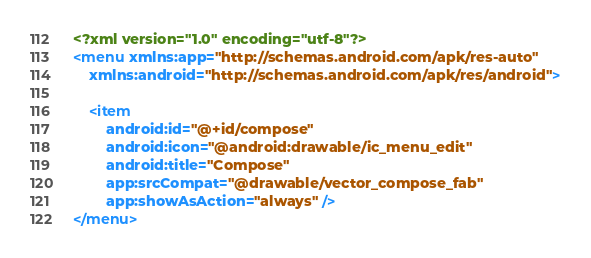<code> <loc_0><loc_0><loc_500><loc_500><_XML_><?xml version="1.0" encoding="utf-8"?>
<menu xmlns:app="http://schemas.android.com/apk/res-auto"
    xmlns:android="http://schemas.android.com/apk/res/android">

    <item
        android:id="@+id/compose"
        android:icon="@android:drawable/ic_menu_edit"
        android:title="Compose"
        app:srcCompat="@drawable/vector_compose_fab"
        app:showAsAction="always" />
</menu></code> 